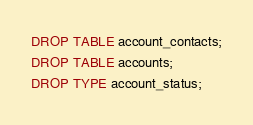Convert code to text. <code><loc_0><loc_0><loc_500><loc_500><_SQL_>DROP TABLE account_contacts;
DROP TABLE accounts;
DROP TYPE account_status;</code> 